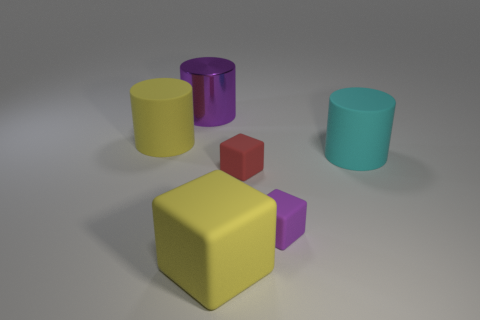Are there any other things that are the same material as the large purple cylinder?
Keep it short and to the point. No. There is a thing left of the big purple cylinder; what material is it?
Make the answer very short. Rubber. There is a big yellow thing in front of the big rubber thing that is behind the big cylinder that is to the right of the metal cylinder; what is its shape?
Ensure brevity in your answer.  Cube. Does the red rubber thing have the same size as the cyan thing?
Offer a terse response. No. How many things are yellow matte things or rubber cylinders that are behind the big cyan object?
Your answer should be very brief. 2. What number of things are big objects that are behind the purple matte block or things in front of the metal thing?
Provide a short and direct response. 6. Are there any matte objects in front of the yellow cylinder?
Your answer should be compact. Yes. What color is the large cylinder that is to the right of the matte thing that is in front of the small rubber object to the right of the red thing?
Your response must be concise. Cyan. Do the tiny purple rubber object and the red rubber thing have the same shape?
Offer a very short reply. Yes. What color is the cylinder that is the same material as the large cyan thing?
Your answer should be very brief. Yellow. 